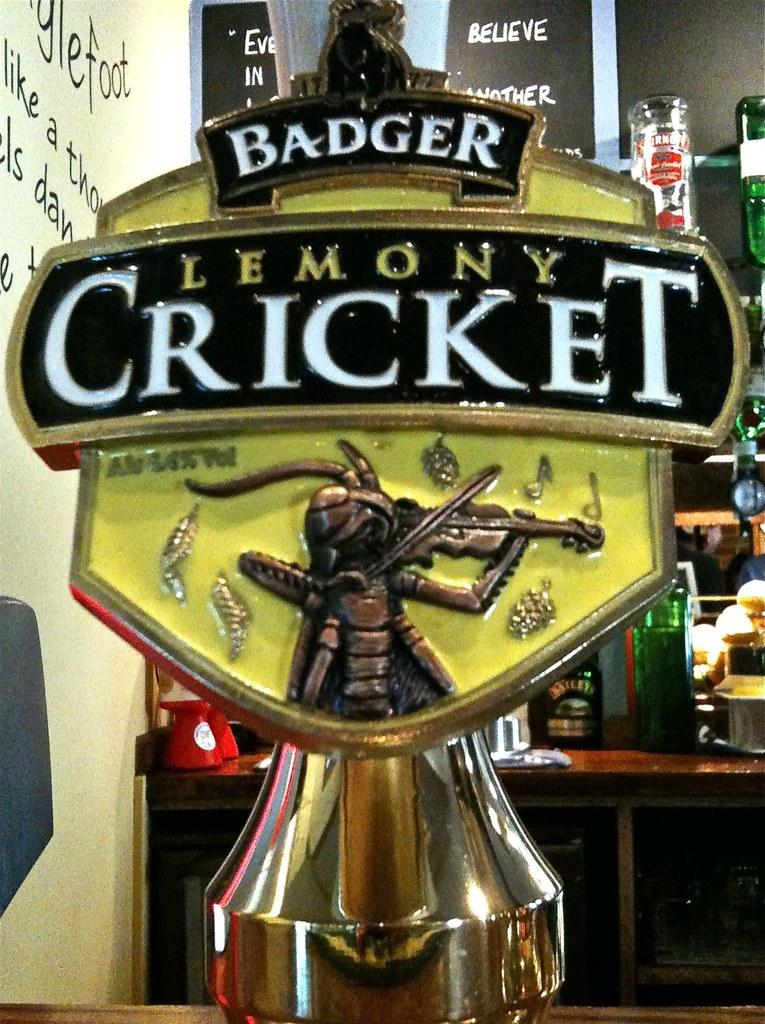<image>
Share a concise interpretation of the image provided. a figure that says 'badger lemony cricket' on it 